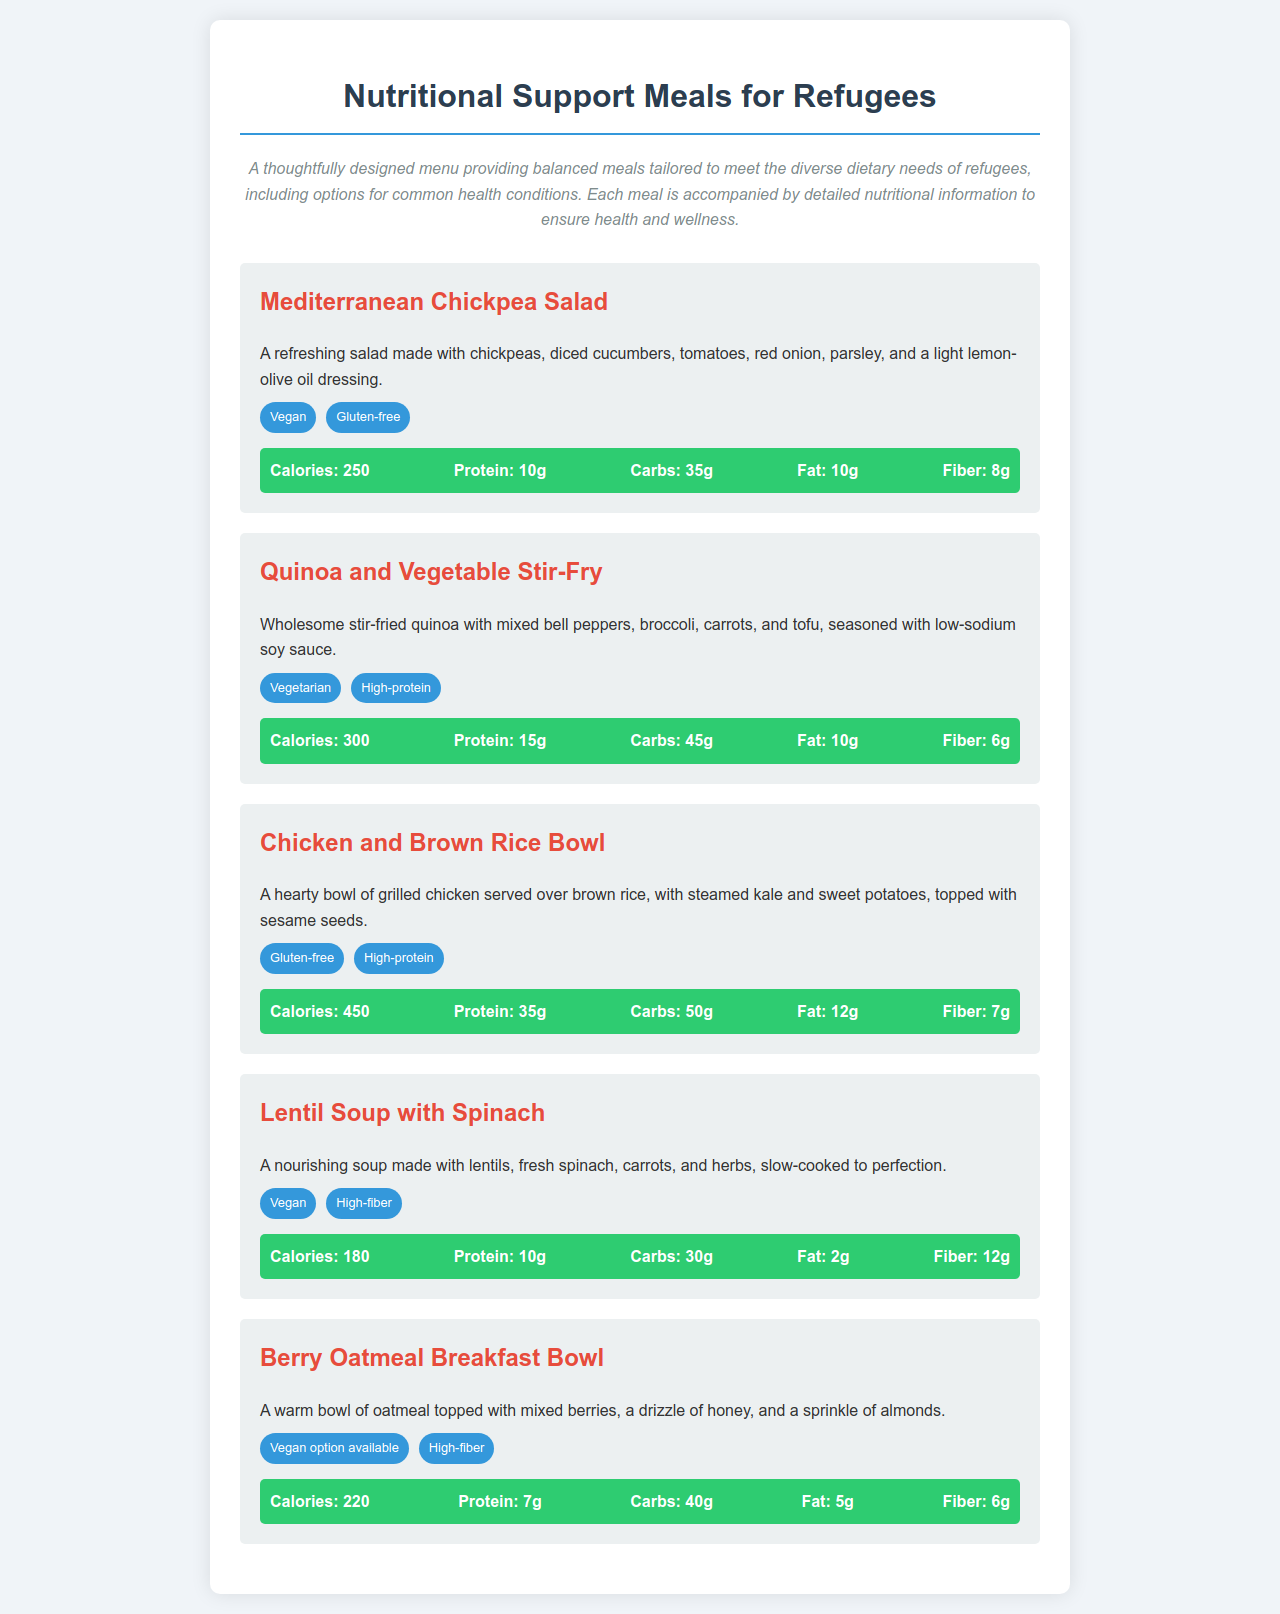What is the first meal listed on the menu? The first meal mentioned in the menu is "Mediterranean Chickpea Salad."
Answer: Mediterranean Chickpea Salad How many grams of protein are in the Chicken and Brown Rice Bowl? The Chicken and Brown Rice Bowl contains 35 grams of protein.
Answer: 35g What dietary requirement does the Lentil Soup with Spinach fulfill? The Lentil Soup with Spinach is labeled as "Vegan" and "High-fiber."
Answer: Vegan, High-fiber What is the calorie count for the Berry Oatmeal Breakfast Bowl? The Berry Oatmeal Breakfast Bowl has a total of 220 calories.
Answer: 220 Which meal has the highest fat content? The meal with the highest fat content is the Chicken and Brown Rice Bowl, which contains 12 grams of fat.
Answer: 12g How many grams of fiber are in the Mediterranean Chickpea Salad? The Mediterranean Chickpea Salad contains 8 grams of fiber.
Answer: 8g What type of dressing is used in the Mediterranean Chickpea Salad? The Mediterranean Chickpea Salad is dressed with a light lemon-olive oil dressing.
Answer: Lemon-olive oil dressing Is a vegan option available for the Berry Oatmeal Breakfast Bowl? Yes, a vegan option is available for the Berry Oatmeal Breakfast Bowl.
Answer: Yes 